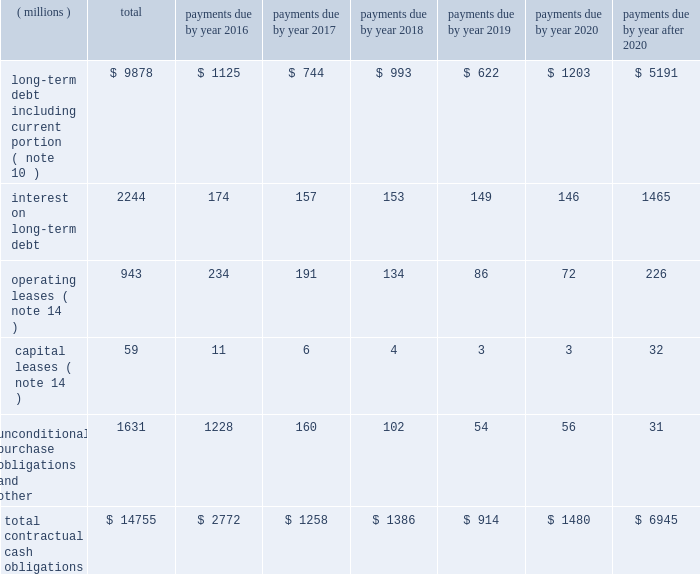A summary of the company 2019s significant contractual obligations as of december 31 , 2015 , follows : contractual obligations .
Long-term debt payments due in 2016 and 2017 include floating rate notes totaling $ 126 million ( classified as current portion of long-term debt ) , and $ 96 million ( included as a separate floating rate note in the long-term debt table ) , respectively , as a result of put provisions associated with these debt instruments .
Interest projections on both floating and fixed rate long-term debt , including the effects of interest rate swaps , are based on effective interest rates as of december 31 , 2015 .
Unconditional purchase obligations are defined as an agreement to purchase goods or services that is enforceable and legally binding on the company .
Included in the unconditional purchase obligations category above are certain obligations related to take or pay contracts , capital commitments , service agreements and utilities .
These estimates include both unconditional purchase obligations with terms in excess of one year and normal ongoing purchase obligations with terms of less than one year .
Many of these commitments relate to take or pay contracts , in which 3m guarantees payment to ensure availability of products or services that are sold to customers .
The company expects to receive consideration ( products or services ) for these unconditional purchase obligations .
Contractual capital commitments are included in the preceding table , but these commitments represent a small part of the company 2019s expected capital spending in 2016 and beyond .
The purchase obligation amounts do not represent the entire anticipated purchases in the future , but represent only those items for which the company is contractually obligated .
The majority of 3m 2019s products and services are purchased as needed , with no unconditional commitment .
For this reason , these amounts will not provide a reliable indicator of the company 2019s expected future cash outflows on a stand-alone basis .
Other obligations , included in the preceding table within the caption entitled 201cunconditional purchase obligations and other , 201d include the current portion of the liability for uncertain tax positions under asc 740 , which is expected to be paid out in cash in the next 12 months .
The company is not able to reasonably estimate the timing of the long-term payments or the amount by which the liability will increase or decrease over time ; therefore , the long-term portion of the net tax liability of $ 208 million is excluded from the preceding table .
Refer to note 8 for further details .
As discussed in note 11 , the company does not have a required minimum cash pension contribution obligation for its u.s .
Plans in 2016 and company contributions to its u.s .
And international pension plans are expected to be largely discretionary in future years ; therefore , amounts related to these plans are not included in the preceding table .
Financial instruments the company enters into foreign exchange forward contracts , options and swaps to hedge against the effect of exchange rate fluctuations on cash flows denominated in foreign currencies and certain intercompany financing transactions .
The company manages interest rate risks using a mix of fixed and floating rate debt .
To help manage borrowing costs , the company may enter into interest rate swaps .
Under these arrangements , the company agrees to exchange , at specified intervals , the difference between fixed and floating interest amounts calculated by reference to an agreed-upon notional principal amount .
The company manages commodity price risks through negotiated supply contracts , price protection agreements and forward contracts. .
What was the percent of the total interest on long-term debt to the total contractual cash obligations? 
Rationale: 15.2% of the total contractual cash obligations was interest on long-term debt to the
Computations: (2244 / 14755)
Answer: 0.15208. 